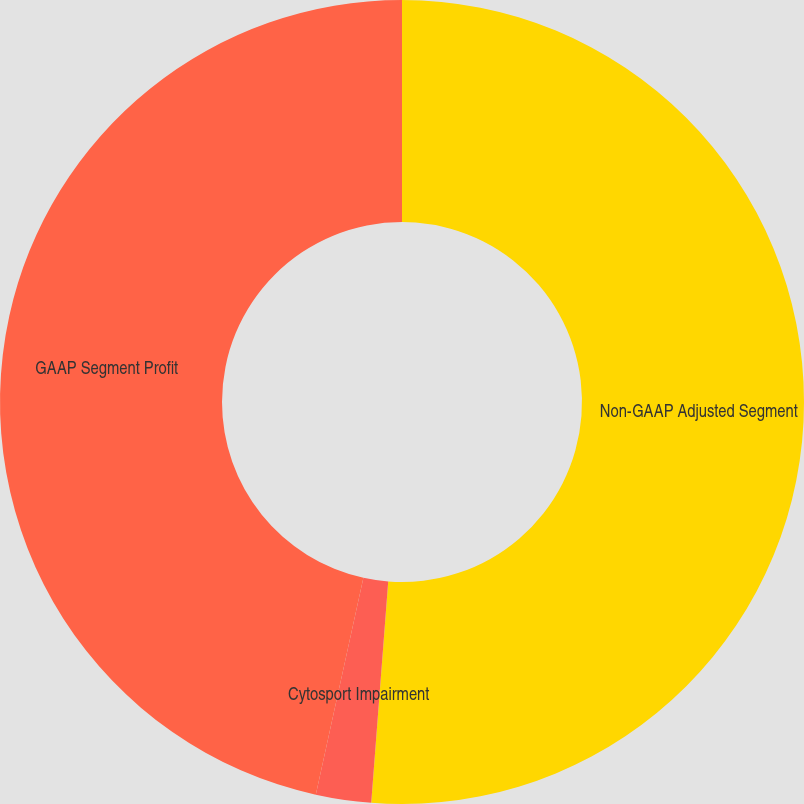Convert chart. <chart><loc_0><loc_0><loc_500><loc_500><pie_chart><fcel>Non-GAAP Adjusted Segment<fcel>Cytosport Impairment<fcel>GAAP Segment Profit<nl><fcel>51.22%<fcel>2.22%<fcel>46.56%<nl></chart> 